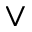<formula> <loc_0><loc_0><loc_500><loc_500>\vee</formula> 